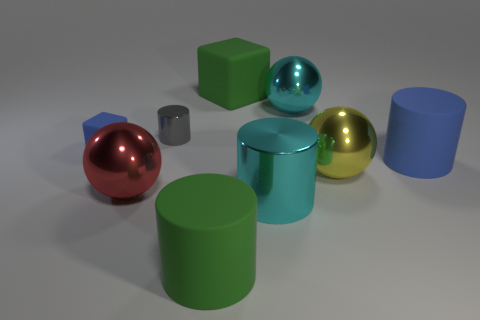Subtract all yellow blocks. Subtract all green spheres. How many blocks are left? 2 Add 1 big yellow metallic objects. How many objects exist? 10 Subtract all balls. How many objects are left? 6 Subtract 1 cyan cylinders. How many objects are left? 8 Subtract all big green cylinders. Subtract all gray cylinders. How many objects are left? 7 Add 3 tiny blue cubes. How many tiny blue cubes are left? 4 Add 7 blue objects. How many blue objects exist? 9 